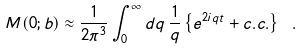<formula> <loc_0><loc_0><loc_500><loc_500>M ( 0 ; b ) \approx \frac { 1 } { 2 \pi ^ { 3 } } \int _ { 0 } ^ { \infty } d q \, \frac { 1 } { q } \left \{ e ^ { 2 i q t } + c . c . \right \} \ .</formula> 